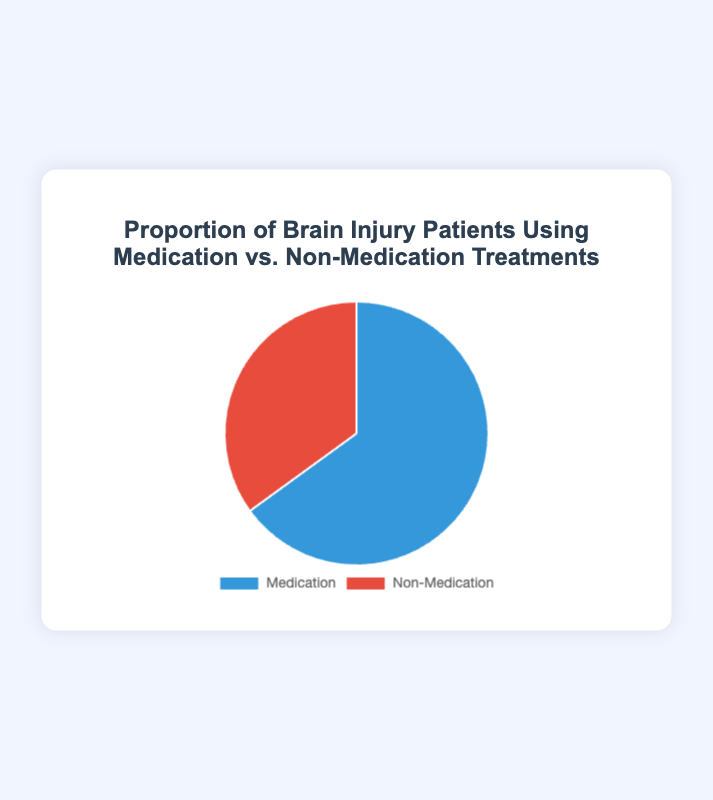What proportion of brain injury patients are using medication treatments? The figure shows a pie chart with a segment for "Medication". The proportion listed on that segment is 65%.
Answer: 65% What is the difference in proportions between patients using medication treatments and those using non-medication treatments? The figure shows 65% for medication treatments and 35% for non-medication treatments. The difference is calculated as 65% - 35% = 30%.
Answer: 30% Which treatment type is used more by brain injury patients? The figure has segments labeled "Medication" and "Non-Medication". The "Medication" segment clearly has a larger proportion, 65%, compared to 35% for "Non-Medication".
Answer: Medication How many times greater is the proportion of patients using medication treatments compared to non-medication treatments? The proportion for medication treatments is 65% and for non-medication treatments is 35%. To find how many times greater, divide 65 by 35, which gives approximately 1.86 times.
Answer: 1.86 times What colors represent medication and non-medication treatments in the pie chart? The legend by the pie chart indicates that the "Medication" segment is represented by blue and the "Non-Medication" segment is represented by red.
Answer: Blue and red If a total of 200 brain injury patients participated in the study, how many of them are using non-medication treatments? The figure indicates that 35% of patients use non-medication treatments. To find the number of patients: 200 * 0.35 = 70.
Answer: 70 What is the total proportion of brain injury patients represented in the pie chart? Pie charts always account for 100% of the data being represented. Since there are only two segments, Medication and Non-Medication, their proportions sum up to 100%.
Answer: 100% Would the size of the Medication segment decrease or increase if more patients switched to non-medication treatments? If patients switch from medication treatments to non-medication treatments, the proportion for medication treatments would decrease, and the proportion for non-medication treatments would increase.
Answer: Decrease What visual feature can help you differentiate between patients using medication and non-medication treatments in the pie chart? The color of the segments in the pie chart helps differentiate between the two treatments: blue for Medication and red for Non-Medication.
Answer: Color What is the sum of the proportions of patients using medication and non-medication treatments? Adding the proportions of the two segments, 65% for Medication and 35% for Non-Medication, results in 65% + 35% = 100%.
Answer: 100% 